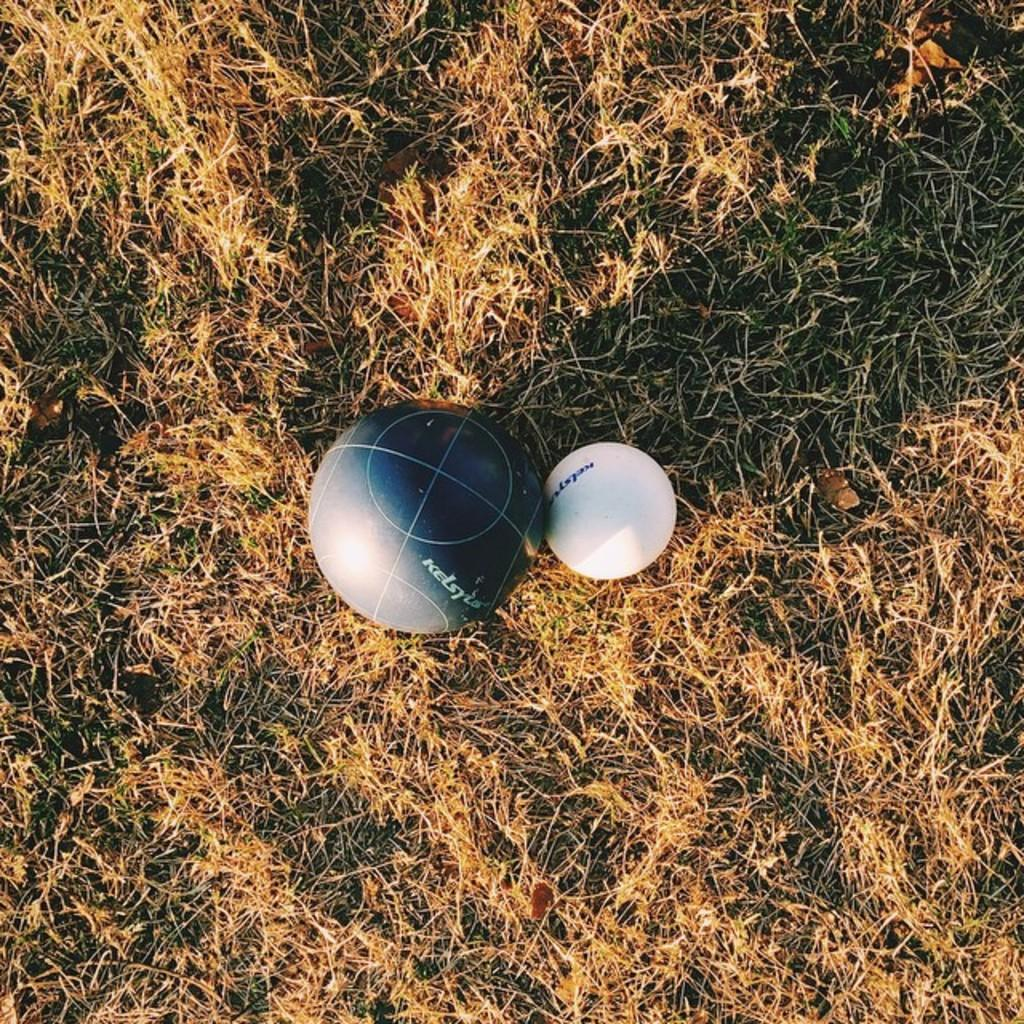What type of vegetation is at the bottom of the image? There is dry grass at the bottom of the image. What objects can be seen in the middle of the image? There are balls in white and grey colors in the middle of the image. How many feet are visible in the image? There are no feet visible in the image. What type of rodent can be seen interacting with the balls in the image? There is no rodent present in the image; only dry grass and balls are visible. 